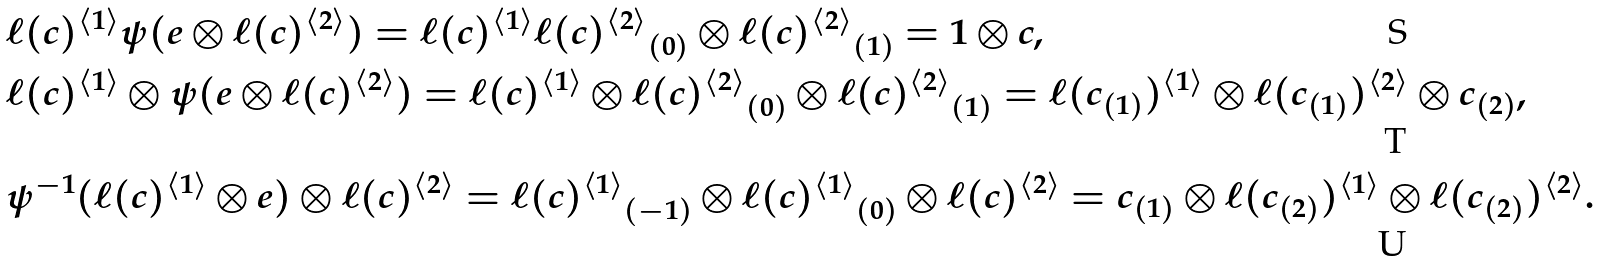<formula> <loc_0><loc_0><loc_500><loc_500>& \ell ( c ) ^ { \langle 1 \rangle } \psi ( e \otimes { \ell ( c ) ^ { \langle 2 \rangle } } ) = \ell ( c ) ^ { \langle 1 \rangle } { \ell ( c ) ^ { \langle 2 \rangle } } _ { ( 0 ) } \otimes { \ell ( c ) ^ { \langle 2 \rangle } } _ { ( 1 ) } = 1 \otimes c , \\ & \ell ( c ) ^ { \langle 1 \rangle } \otimes \psi ( e \otimes { \ell ( c ) ^ { \langle 2 \rangle } } ) = \ell ( c ) ^ { \langle 1 \rangle } \otimes { \ell ( c ) ^ { \langle 2 \rangle } } _ { ( 0 ) } \otimes { \ell ( c ) ^ { \langle 2 \rangle } } _ { ( 1 ) } = \ell ( c _ { ( 1 ) } ) ^ { \langle 1 \rangle } \otimes \ell ( c _ { ( 1 ) } ) ^ { \langle 2 \rangle } \otimes c _ { ( 2 ) } , \\ & \psi ^ { - 1 } ( { \ell ( c ) ^ { \langle 1 \rangle } } \otimes e ) \otimes \ell ( c ) ^ { \langle 2 \rangle } = { \ell ( c ) ^ { \langle 1 \rangle } } _ { ( - 1 ) } \otimes { \ell ( c ) ^ { \langle 1 \rangle } } _ { ( 0 ) } \otimes \ell ( c ) ^ { \langle 2 \rangle } = c _ { ( 1 ) } \otimes \ell ( c _ { ( 2 ) } ) ^ { \langle 1 \rangle } \otimes \ell ( c _ { ( 2 ) } ) ^ { \langle 2 \rangle } .</formula> 